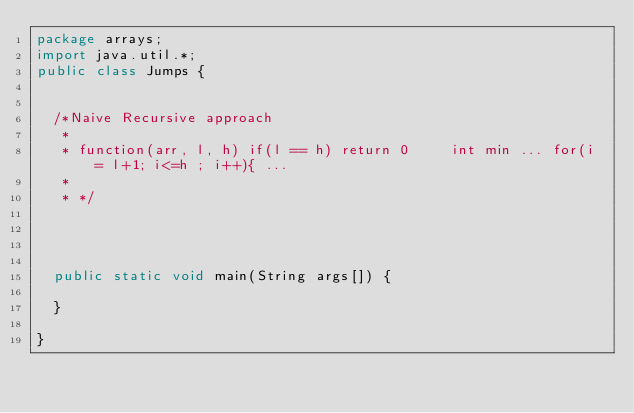<code> <loc_0><loc_0><loc_500><loc_500><_Java_>package arrays;
import java.util.*;
public class Jumps {
	
	
	/*Naive Recursive approach
	 * 
	 * function(arr, l, h) if(l == h) return 0     int min ... for(i = l+1; i<=h ; i++){ ...
	 * 
	 * */
	
	
	
	
	public static void main(String args[]) {
		
	}
	
}
</code> 